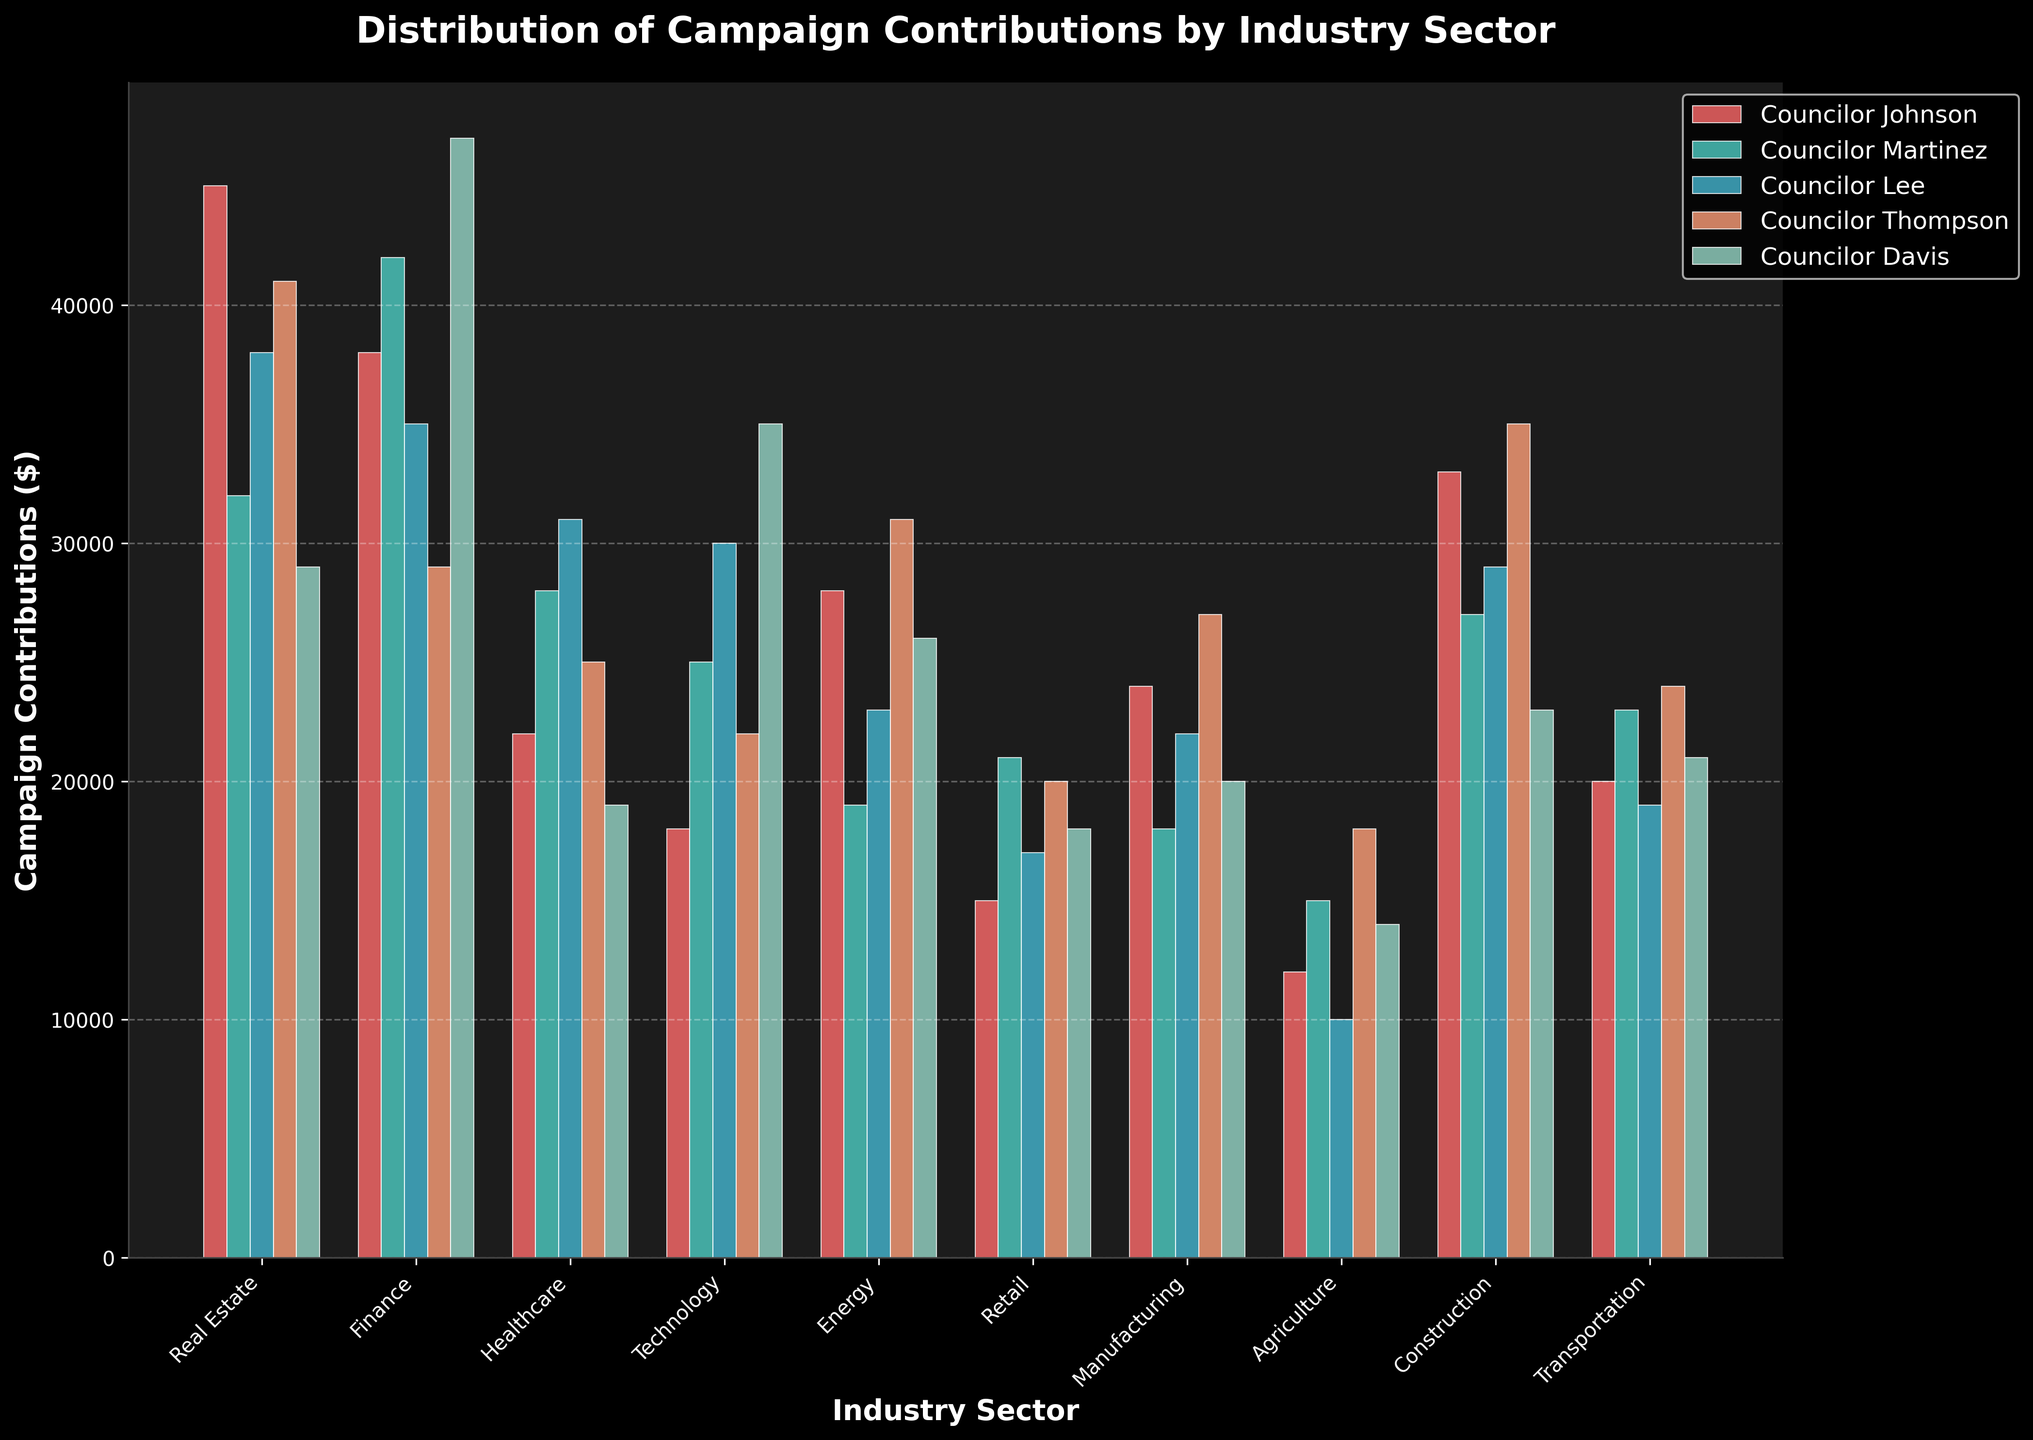Which council member received the highest total campaign contributions from all industry sectors combined? Sum the contributions for each council member across all sectors and compare. Johnson: (45000+38000+22000+18000+28000+15000+24000+12000+33000+20000) = 255000; Martinez: (32000+42000+28000+25000+19000+21000+18000+15000+27000+23000) = 250000; Lee: (38000+35000+31000+30000+23000+17000+22000+10000+29000+19000) = 254000; Thompson: (41000+29000+25000+22000+31000+20000+27000+18000+35000+24000) = 272000; Davis: (29000+47000+19000+35000+26000+18000+20000+14000+23000+21000) = 252000. Thompson received the highest with 272000.
Answer: Thompson Which industry sector contributed the most total campaign contributions across all council members? Sum the contributions for each industry sector across all council members and compare. Real Estate: (45000+32000+38000+41000+29000) = 185000; Finance: (38000+42000+35000+29000+47000) = 191000; Healthcare: (22000+28000+31000+25000+19000) = 125000; Technology: (18000+25000+30000+22000+35000) = 130000; Energy: (28000+19000+23000+31000+26000) = 127000; Retail: (15000+21000+17000+20000+18000) = 91000; Manufacturing: (24000+18000+22000+27000+20000) = 111000; Agriculture: (12000+15000+10000+18000+14000) = 69000; Construction: (33000+27000+29000+35000+23000) = 147000; Transportation: (20000+23000+19000+24000+21000) = 107000. Finance contributed the most with 191000.
Answer: Finance Which council member received the least contributions from the Healthcare sector? Compare the heights of the bars in the Healthcare sector for all council members. The contributions are Johnson (22000), Martinez (28000), Lee (31000), Thompson (25000), Davis (19000). Therefore, Davis received the least at 19000.
Answer: Davis By how much did contributions from the Technology sector to Councilor Davis exceed those to Councilor Johnson? Find the difference between the contributions for Davis and Johnson in the Technology sector. Davis: 35000, Johnson: 18000. Difference: 35000 - 18000 = 17000.
Answer: 17000 What is the combined total of contributions received by Councilor Martinez from the Real Estate, Finance, and Healthcare sectors? Sum the contributions from these sectors for Martinez: Real Estate (32000) + Finance (42000) + Healthcare (28000) = 102000.
Answer: 102000 Which industry sector shows the smallest variation in contributions across all council members? Calculate the range for each sector and compare. The ranges are: Real Estate: 16000, Finance: 18000, Healthcare: 12000, Technology: 17000, Energy: 12000, Retail: 6000, Manufacturing: 9000, Agriculture: 8000, Construction: 12000, Transportation: 5000. Transportation has the smallest variation with 5000 difference.
Answer: Transportation How much more did Councilor Thompson receive from the Energy sector compared to Manufacturing? Find the difference between contributions from the Energy and Manufacturing sectors for Thompson. Energy: 31000, Manufacturing: 27000. Difference: 31000 - 27000 = 4000.
Answer: 4000 Which council member received more contributions from the Agriculture sector: Councilor Lee or Councilor Martinez? Compare the bars for the Agriculture sector. Contributions for Lee: 10000, for Martinez: 15000. Therefore, Martinez received more.
Answer: Martinez What is the average campaign contribution from the Real Estate sector across all council members? Sum the contributions from the Real Estate sector and divide by the number of council members: (45000 + 32000 + 38000 + 41000 + 29000) / 5 = 37000.
Answer: 37000 